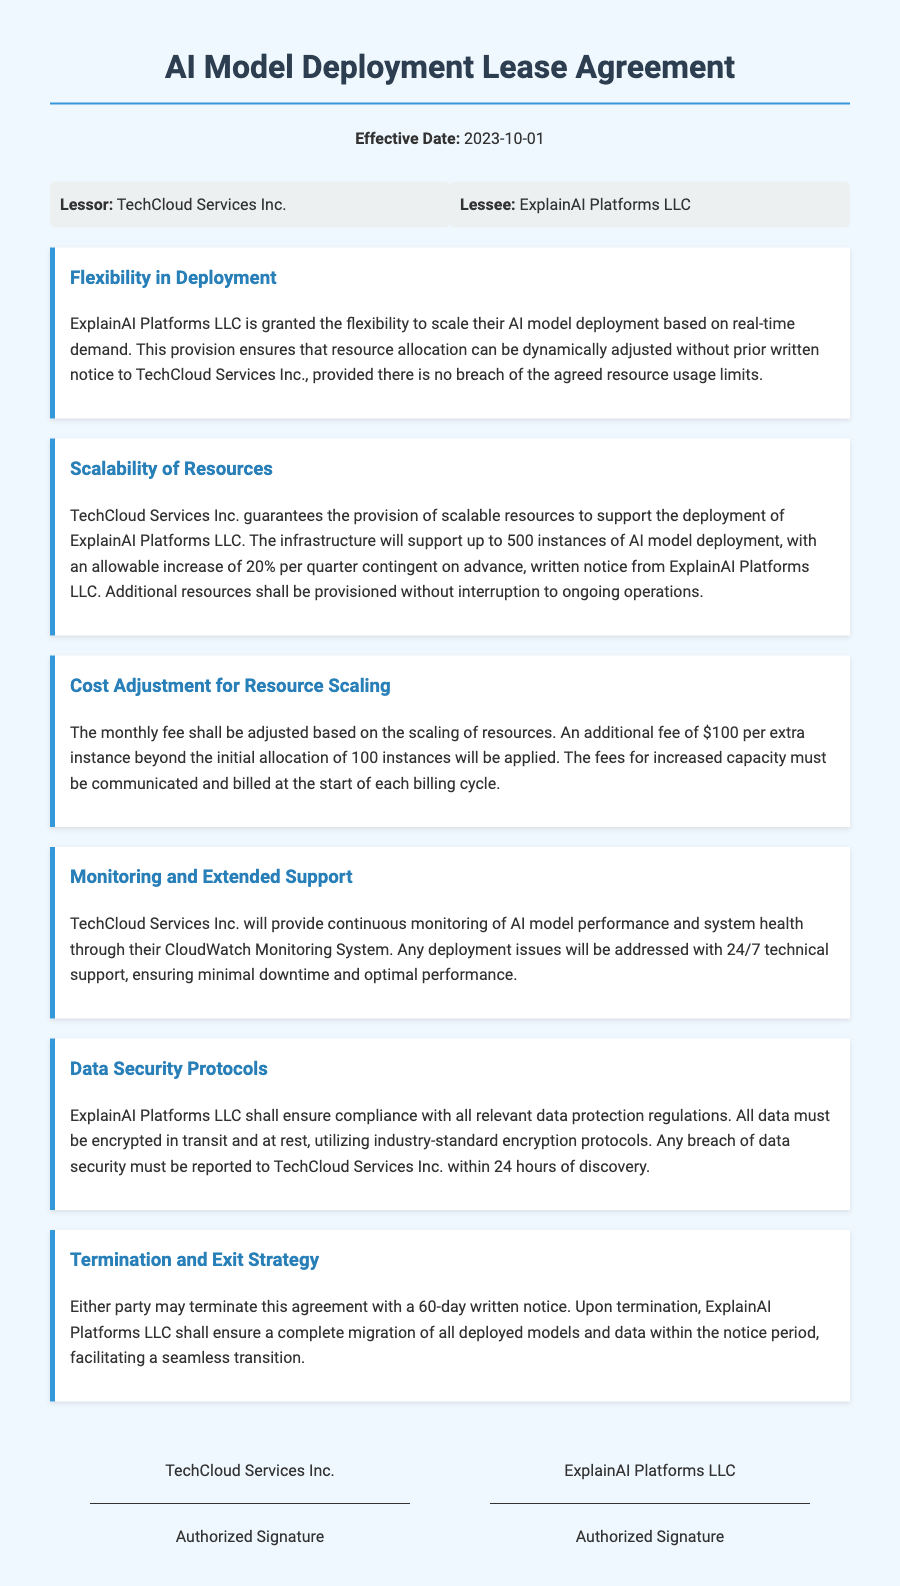what is the effective date of the lease agreement? The effective date can be found at the top of the document under the title, indicating when the lease commences.
Answer: 2023-10-01 who is the lessor in this agreement? The lessor's name can be found in the parties section of the document, identifying the entity providing the service.
Answer: TechCloud Services Inc what is the maximum number of AI model deployments supported? The maximum deployment capacity is mentioned in the scalability clause, stating the limit for deployments.
Answer: 500 instances how much is the additional fee for each extra instance beyond the initial allocation? The fee for exceeding the baseline allocation is specified in the cost adjustment clause of the document.
Answer: $100 what notice period is required for termination of the agreement? The termination clause states how much advance notice is needed for either party to end the agreement.
Answer: 60-day what type of support does TechCloud Services Inc. provide? This type of support is detailed in the monitoring and extended support clause, indicating the nature of service provided.
Answer: 24/7 technical support how often can resource capacity be increased? The scalability clause specifies the frequency of allowed capacity expansion requests.
Answer: per quarter what must ExplainAI Platforms LLC ensure regarding data? The data security protocols clause outlines the obligations concerning the handling of data and the standards to be met.
Answer: compliance with all relevant data protection regulations what will happen upon termination of the agreement? The termination and exit strategy clause describes the process and responsibilities following the termination notice.
Answer: complete migration of all deployed models and data 